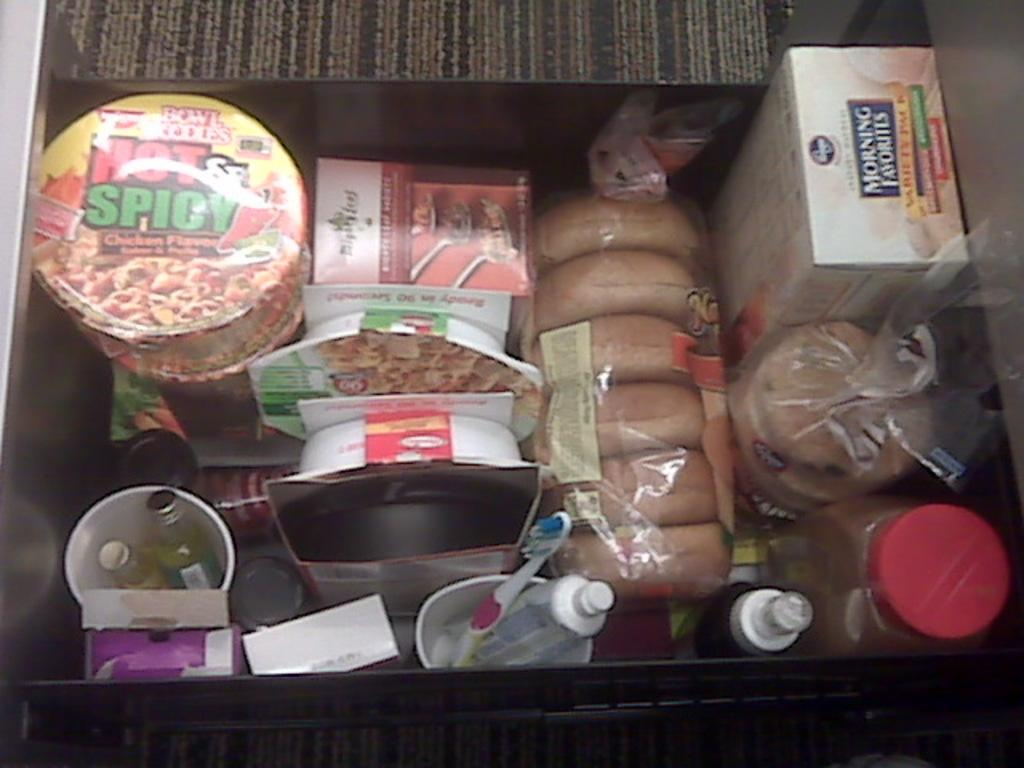What is the focus of the image? The image is zoomed in on a box. What is inside the box? The box contains bottles, a toothbrush, boxes, and food items. Can you describe the contents of the box in more detail? The box contains bottles, a toothbrush, smaller boxes, and various food items. Is there a rifle visible in the image? No, there is no rifle present in the image. Can you provide a guide on how to use the toothbrush in the image? The image does not provide a guide on how to use the toothbrush; it only shows the toothbrush inside the box. 